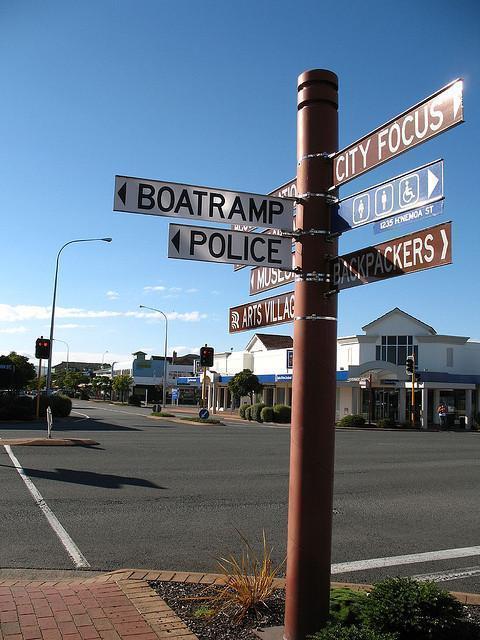What sign should I follow if I have lost my wallet?
Make your selection and explain in format: 'Answer: answer
Rationale: rationale.'
Options: Police, boatramp, city focus, backpackers. Answer: police.
Rationale: When something is missing you should try going to the authorities. 